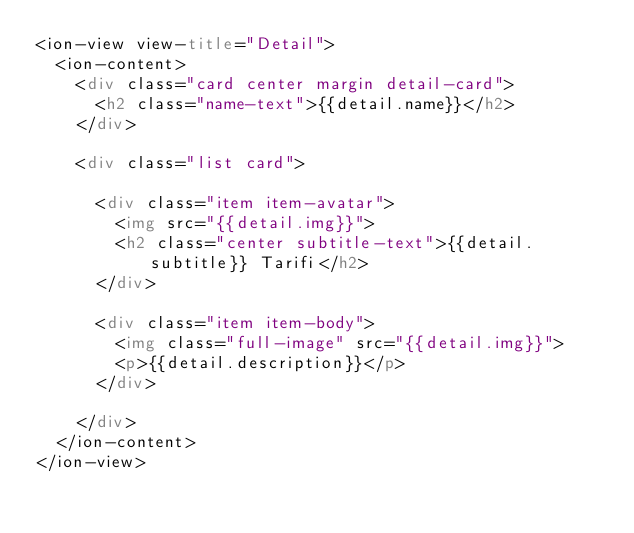<code> <loc_0><loc_0><loc_500><loc_500><_HTML_><ion-view view-title="Detail">
  <ion-content>
    <div class="card center margin detail-card">
      <h2 class="name-text">{{detail.name}}</h2>
    </div>

    <div class="list card">

      <div class="item item-avatar">
        <img src="{{detail.img}}">
        <h2 class="center subtitle-text">{{detail.subtitle}} Tarifi</h2>
      </div>
    
      <div class="item item-body">
        <img class="full-image" src="{{detail.img}}">
        <p>{{detail.description}}</p>
      </div>
    
    </div>
  </ion-content>
</ion-view>
</code> 